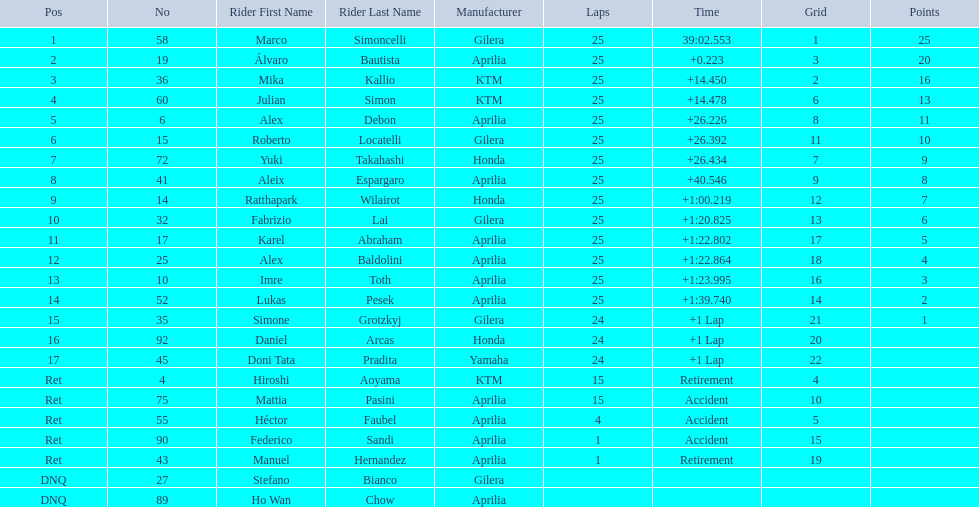What was the fastest overall time? 39:02.553. Who does this time belong to? Marco Simoncelli. 